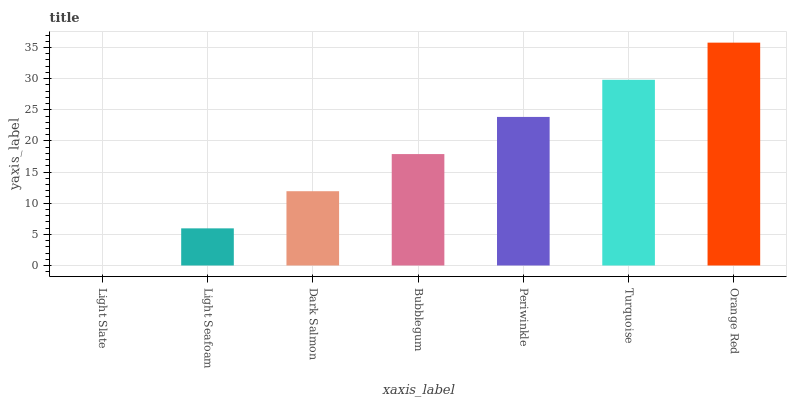Is Light Slate the minimum?
Answer yes or no. Yes. Is Orange Red the maximum?
Answer yes or no. Yes. Is Light Seafoam the minimum?
Answer yes or no. No. Is Light Seafoam the maximum?
Answer yes or no. No. Is Light Seafoam greater than Light Slate?
Answer yes or no. Yes. Is Light Slate less than Light Seafoam?
Answer yes or no. Yes. Is Light Slate greater than Light Seafoam?
Answer yes or no. No. Is Light Seafoam less than Light Slate?
Answer yes or no. No. Is Bubblegum the high median?
Answer yes or no. Yes. Is Bubblegum the low median?
Answer yes or no. Yes. Is Orange Red the high median?
Answer yes or no. No. Is Dark Salmon the low median?
Answer yes or no. No. 